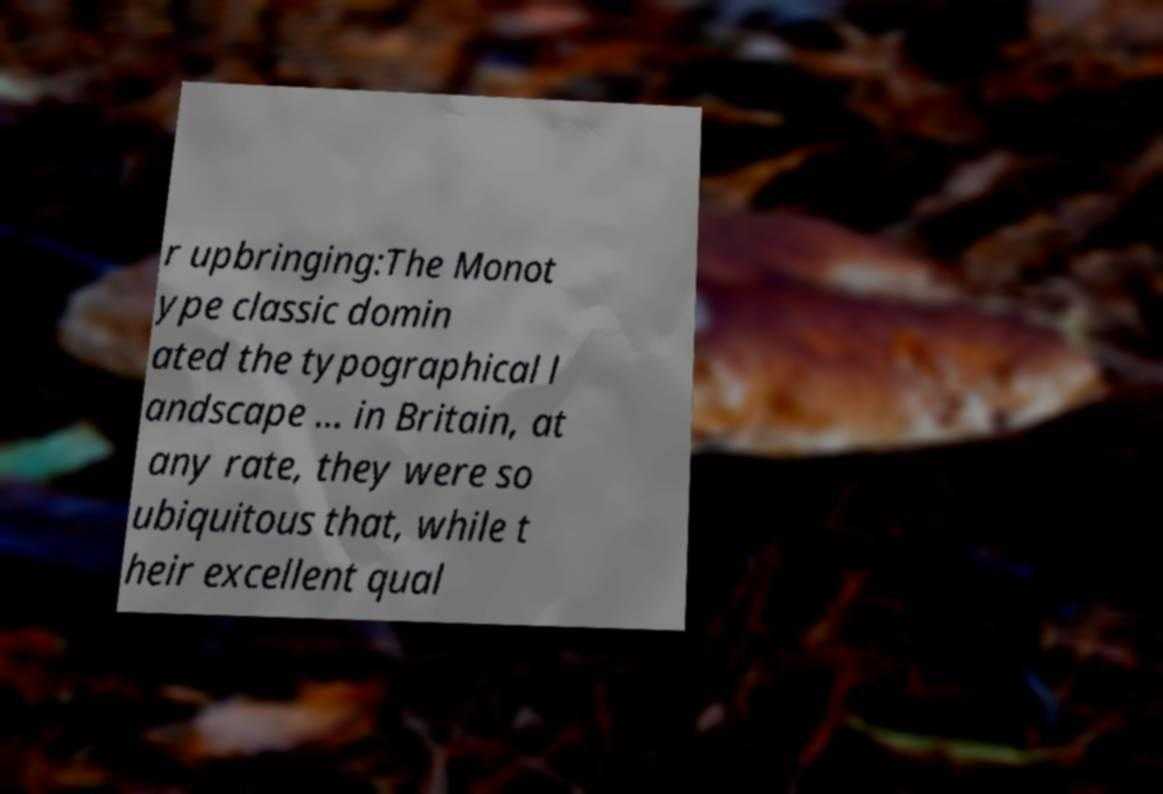Please read and relay the text visible in this image. What does it say? r upbringing:The Monot ype classic domin ated the typographical l andscape ... in Britain, at any rate, they were so ubiquitous that, while t heir excellent qual 